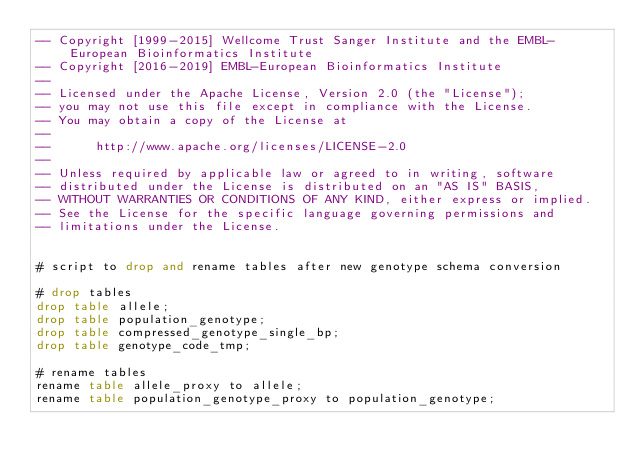Convert code to text. <code><loc_0><loc_0><loc_500><loc_500><_SQL_>-- Copyright [1999-2015] Wellcome Trust Sanger Institute and the EMBL-European Bioinformatics Institute
-- Copyright [2016-2019] EMBL-European Bioinformatics Institute
-- 
-- Licensed under the Apache License, Version 2.0 (the "License");
-- you may not use this file except in compliance with the License.
-- You may obtain a copy of the License at
-- 
--      http://www.apache.org/licenses/LICENSE-2.0
-- 
-- Unless required by applicable law or agreed to in writing, software
-- distributed under the License is distributed on an "AS IS" BASIS,
-- WITHOUT WARRANTIES OR CONDITIONS OF ANY KIND, either express or implied.
-- See the License for the specific language governing permissions and
-- limitations under the License.


# script to drop and rename tables after new genotype schema conversion

# drop tables
drop table allele;
drop table population_genotype;
drop table compressed_genotype_single_bp;
drop table genotype_code_tmp;

# rename tables
rename table allele_proxy to allele;
rename table population_genotype_proxy to population_genotype;</code> 